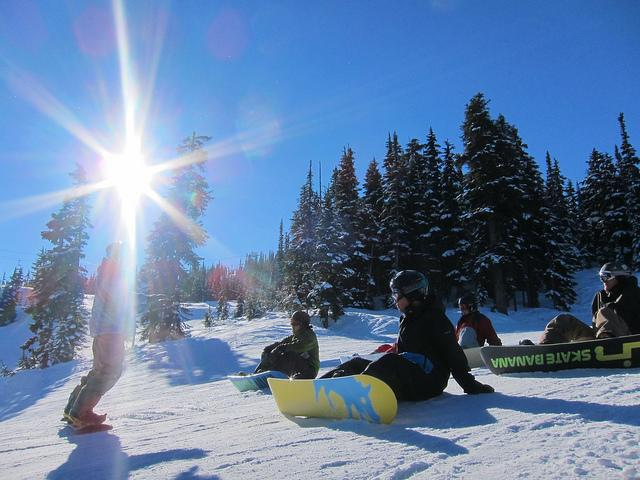Who is the man standing in front of the group? Please explain your reasoning. instructor. The person at the front is facing the group.  each person in the group is facing this individual while engaging in an identical body position with a snowboard. 